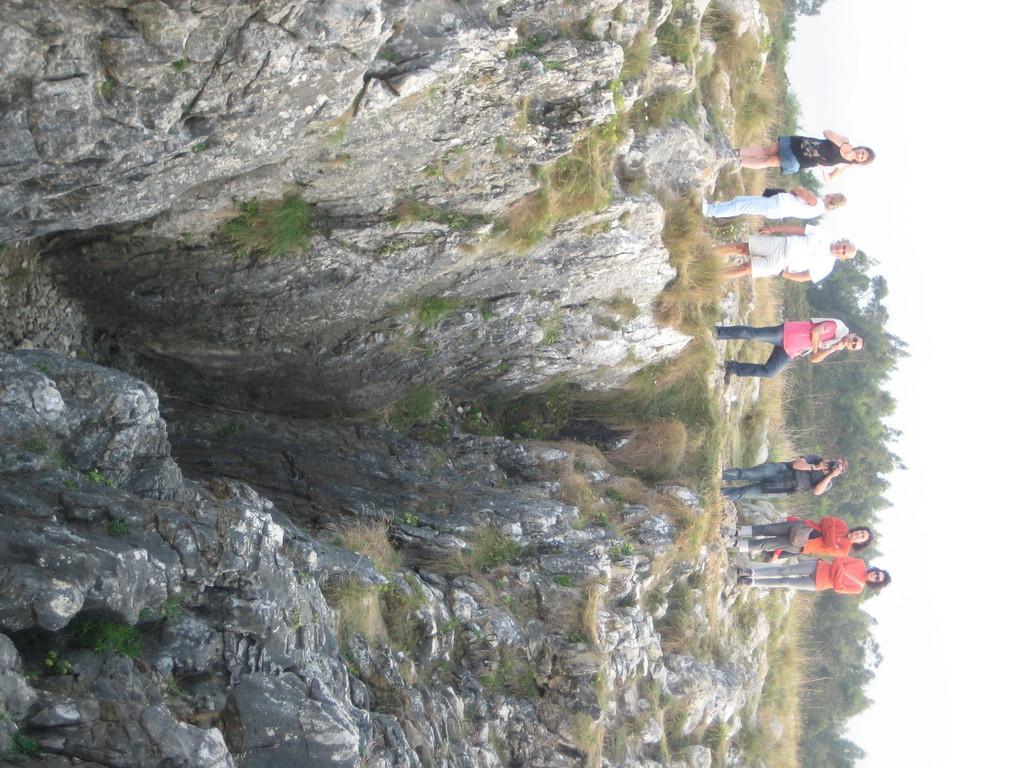How would you summarize this image in a sentence or two? In this image on the right side there are some people who are standing, and on the left side there is a mountain and grass. In the background there are some trees. 